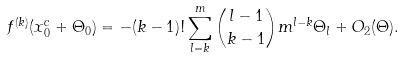<formula> <loc_0><loc_0><loc_500><loc_500>f ^ { ( k ) } ( x _ { 0 } ^ { c } + \Theta _ { 0 } ) = - ( k - 1 ) ! \sum _ { l = k } ^ { m } { \binom { l - 1 } { k - 1 } } m ^ { l - k } \Theta _ { l } + { O } _ { 2 } ( \Theta ) .</formula> 